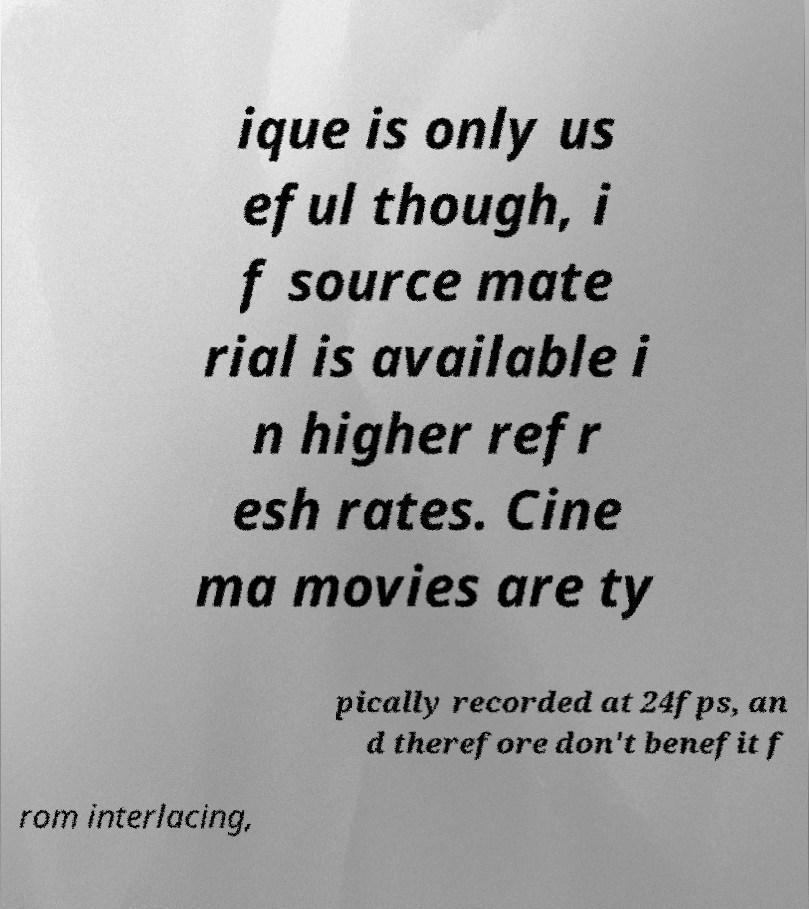Please identify and transcribe the text found in this image. ique is only us eful though, i f source mate rial is available i n higher refr esh rates. Cine ma movies are ty pically recorded at 24fps, an d therefore don't benefit f rom interlacing, 